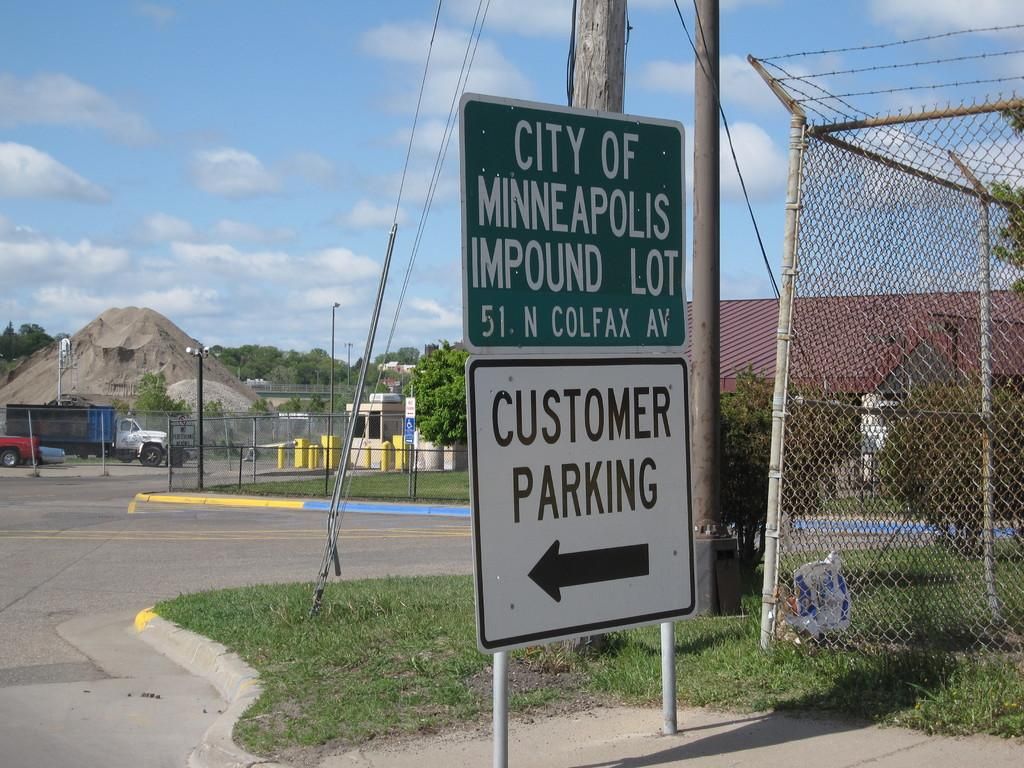Provide a one-sentence caption for the provided image. Sign that says City of Minneapolis Impound Lot and Customer Parking. 